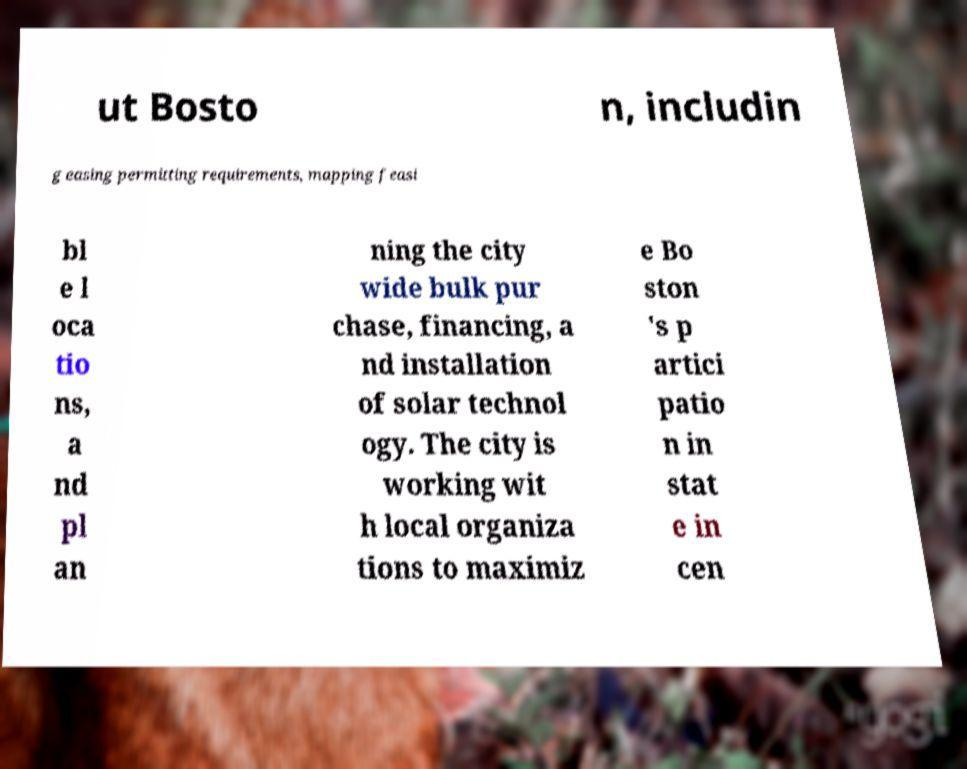I need the written content from this picture converted into text. Can you do that? ut Bosto n, includin g easing permitting requirements, mapping feasi bl e l oca tio ns, a nd pl an ning the city wide bulk pur chase, financing, a nd installation of solar technol ogy. The city is working wit h local organiza tions to maximiz e Bo ston 's p artici patio n in stat e in cen 